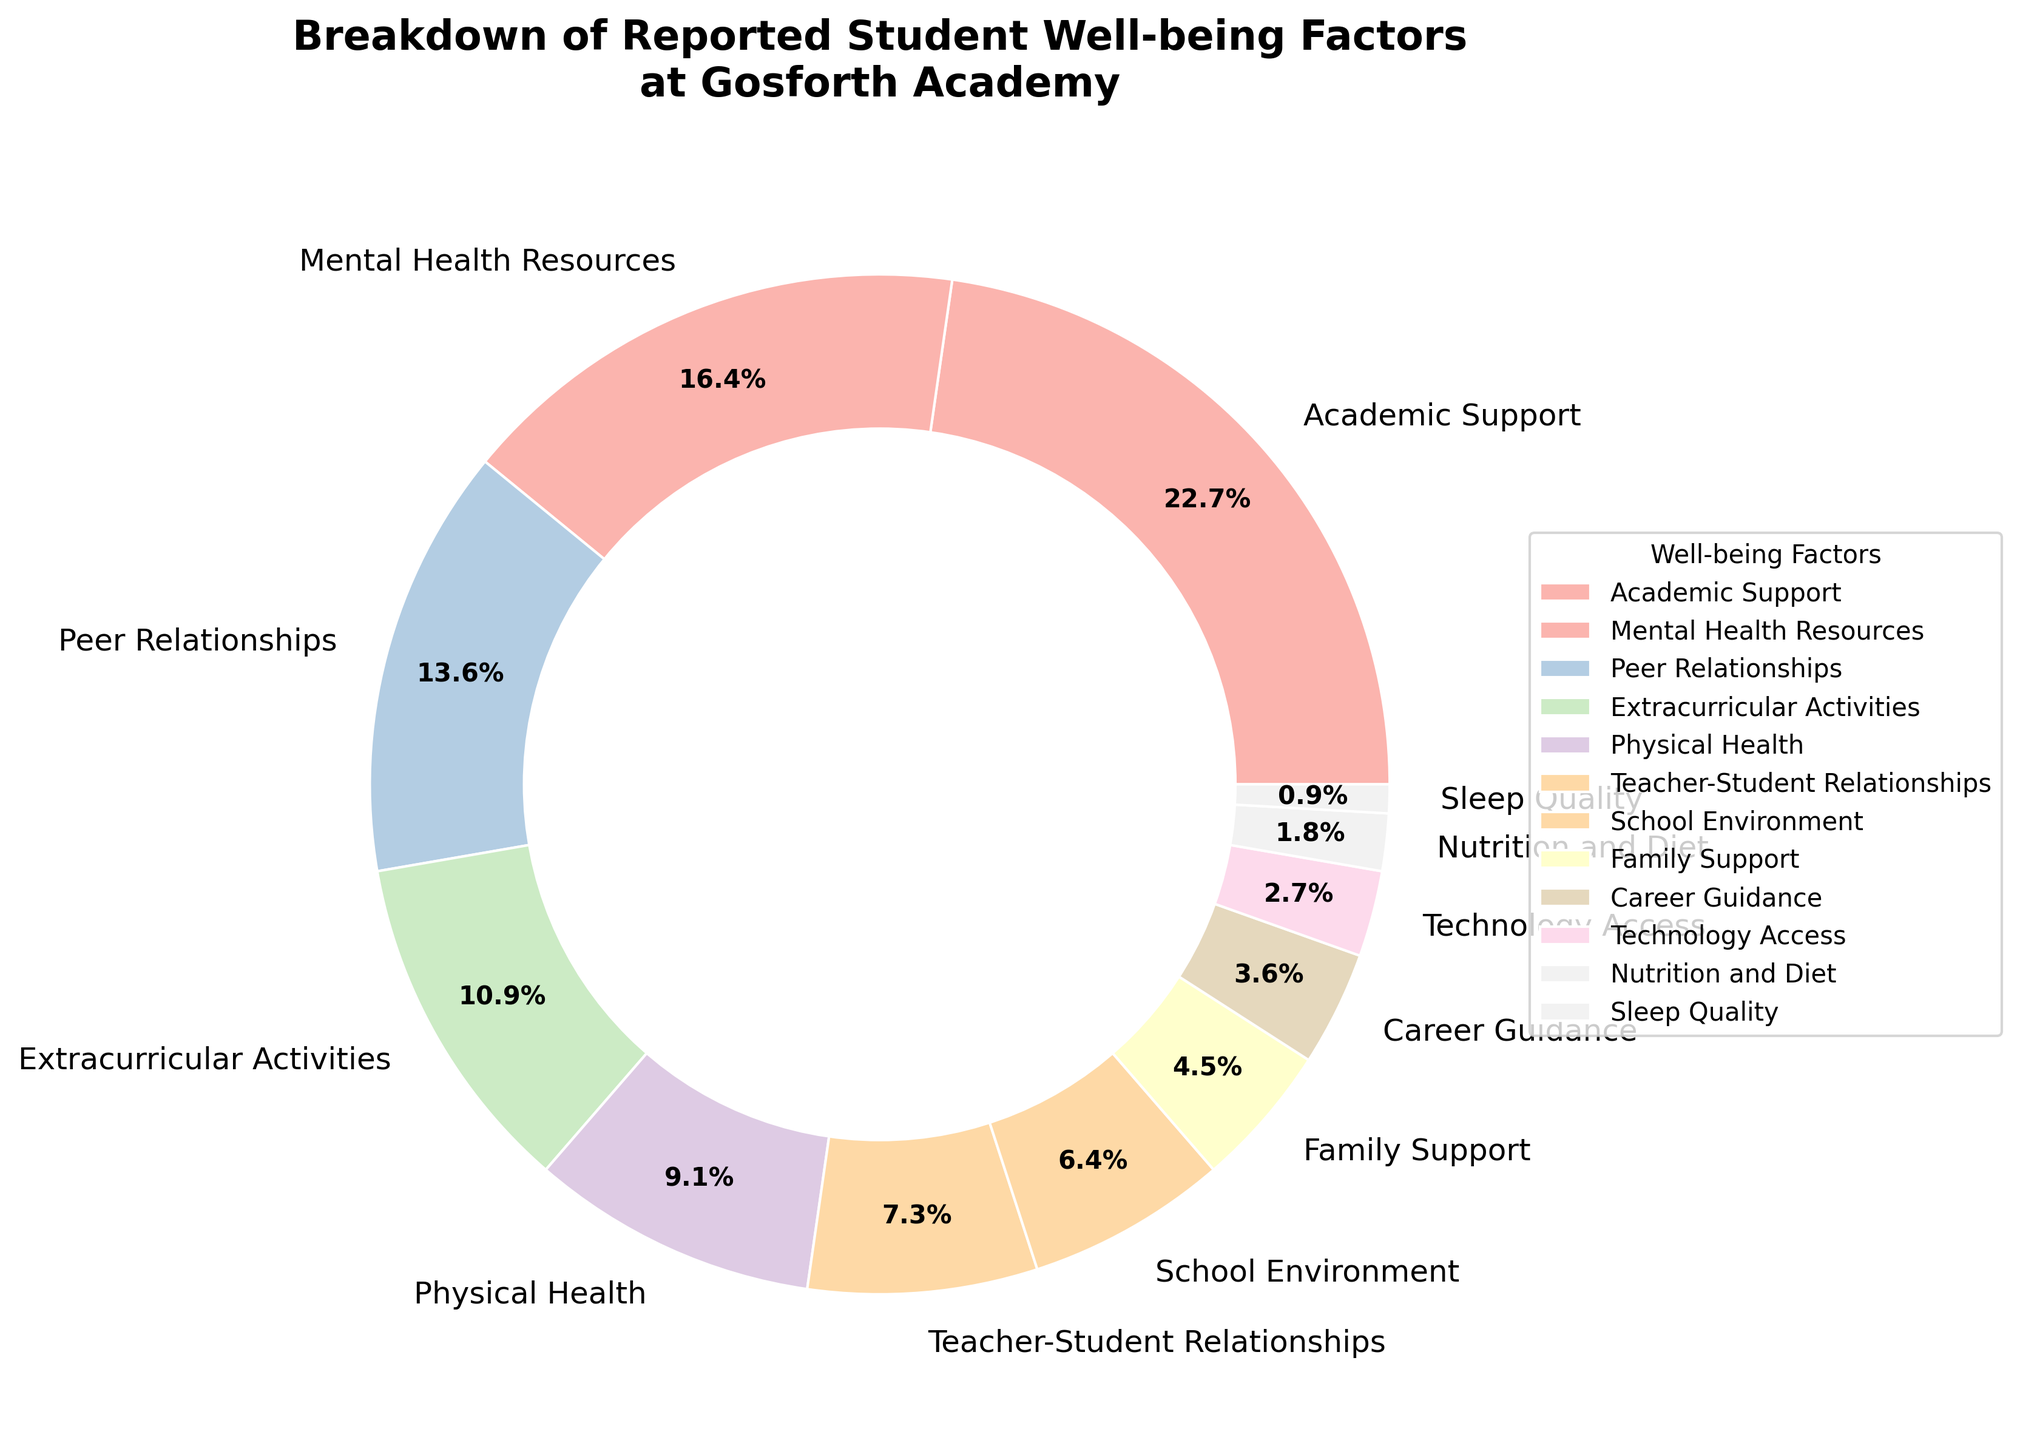What percentage of reported student well-being factors is dedicated to Physical Health? According to the pie chart, the slice for Physical Health indicates its percentage.
Answer: 10% Which well-being factor is shown in the smallest slice of the pie chart? The smallest slice corresponds to Sleep Quality.
Answer: Sleep Quality What is the total percentage contribution of Teacher-Student Relationships and Career Guidance combined? Teacher-Student Relationships contribute 8% and Career Guidance contributes 4%. Adding them gives 8% + 4% = 12%.
Answer: 12% Which well-being factor has a larger contribution: Academic Support or Peer Relationships? Refer to the pie chart slices, Academic Support has 25% while Peer Relationships has 15%. 25% is greater than 15%.
Answer: Academic Support Is the combined contribution of Nutrition and Diet and Sleep Quality significant? Nutrition and Diet contribute 2%, and Sleep Quality contributes 1%. Adding them gives 2% + 1% = 3%. This combined contribution is relatively small compared to others.
Answer: No How much more percentage does Academic Support have compared to Extracurricular Activities? Academic Support has 25% while Extracurricular Activities have 12%. The difference is 25% - 12% = 13%.
Answer: 13% How does the percentage of Mental Health Resources compare to Family Support and Technology Access combined? Mental Health Resources has 18%. Family Support has 5% and Technology Access has 3%, combined they have 5% + 3% = 8%. Comparing them, 18% is greater than 8%.
Answer: Greater Which factors have a percentage contribution between 10% and 20%? According to the chart, the factors with contributions between 10% and 20% are Mental Health Resources (18%) and Peer Relationships (15%).
Answer: Mental Health Resources, Peer Relationships What is the average percentage of factors contributing less than 5%? Factors contributing less than 5% are Career Guidance (4%), Technology Access (3%), Nutrition and Diet (2%), and Sleep Quality (1%). The average is (4% + 3% + 2% + 1%) / 4 = 2.5%.
Answer: 2.5% How many factors contribute less than the percentage contribution of Physical Health? Physical Health contributes 10%. The factors contributing less than 10% are Teacher-Student Relationships (8%), School Environment (7%), Family Support (5%), Career Guidance (4%), Technology Access (3%), Nutrition and Diet (2%), and Sleep Quality (1%). There are 7 factors.
Answer: 7 factors 